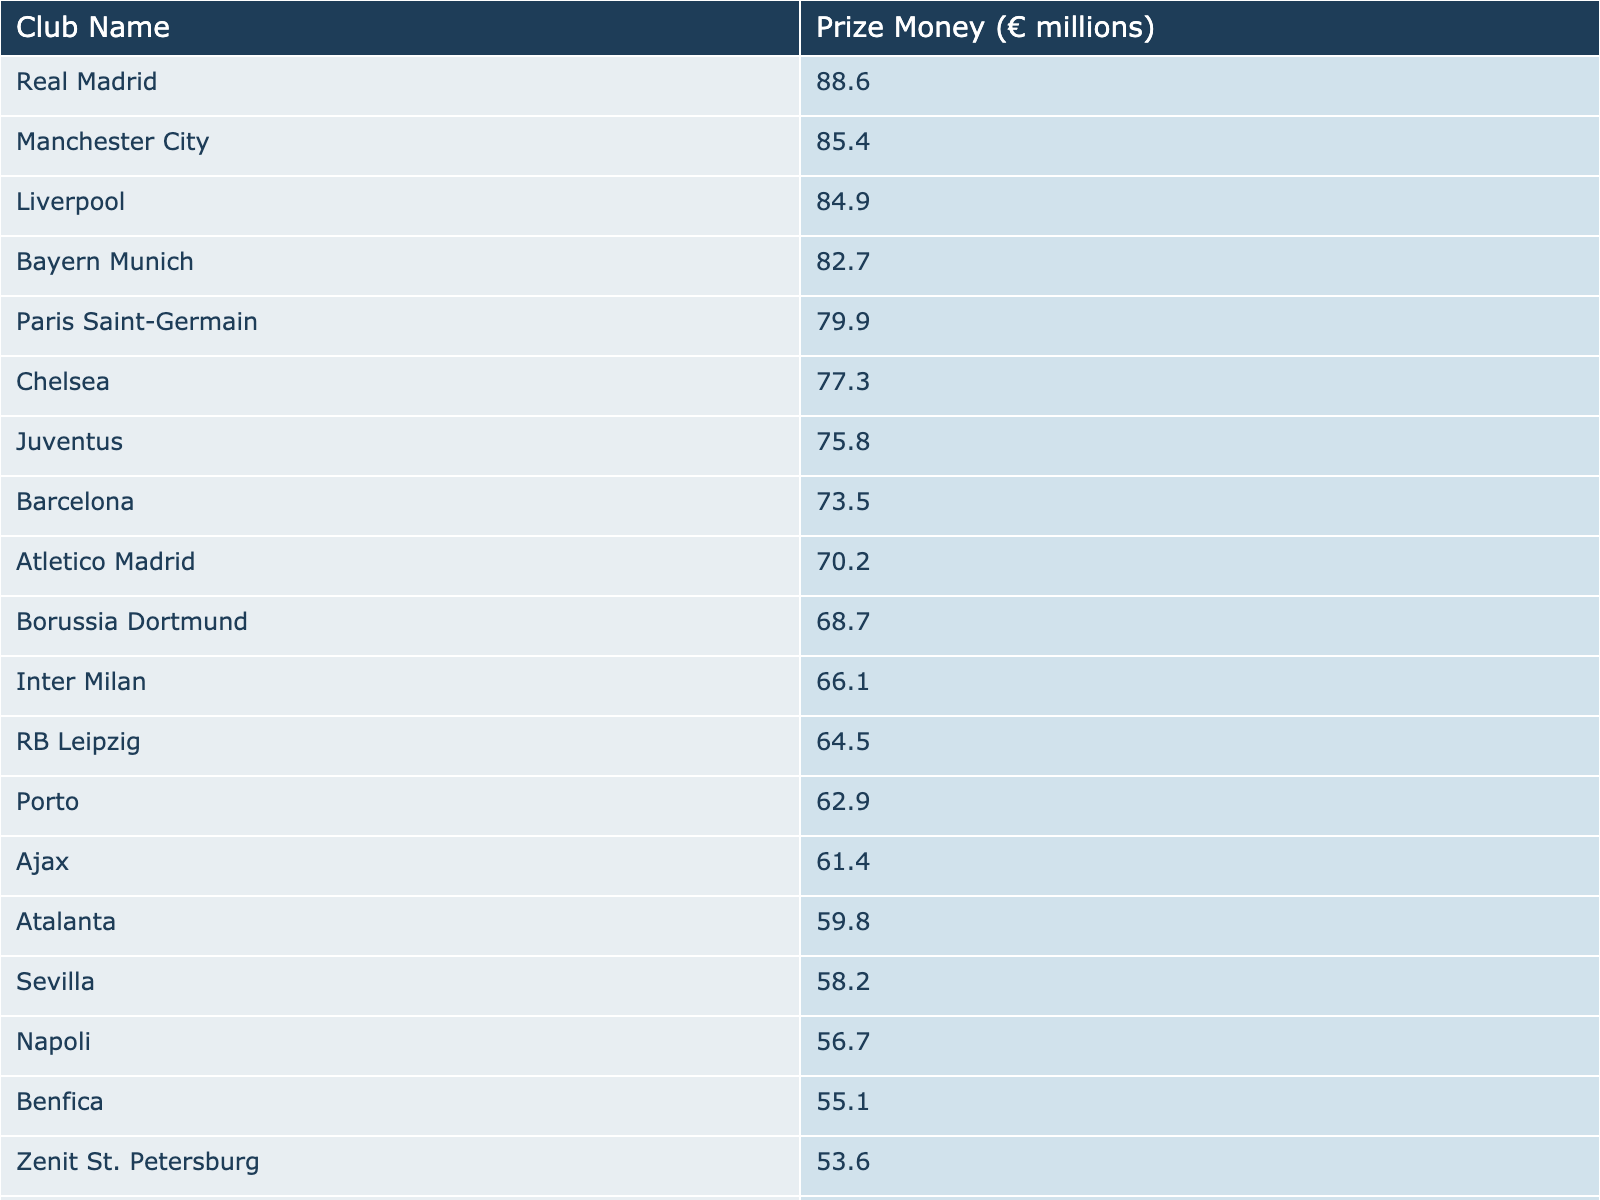What is the prize money for Manchester City? The table lists Manchester City with a prize money of €85.4 million.
Answer: 85.4 million Which club received the least prize money? By examining the table, Lyon has the least prize money listed at €52.0 million.
Answer: Lyon What is the prize money difference between Chelsea and Juventus? Chelsea's prize money is €77.3 million, while Juventus's is €75.8 million. The difference is €77.3 million - €75.8 million = €1.5 million.
Answer: 1.5 million How much total prize money did the top three clubs receive? The top three clubs' prize money sums up to €88.6 million (Real Madrid) + €85.4 million (Manchester City) + €84.9 million (Liverpool) = €258.9 million.
Answer: 258.9 million Is the prize money for Barcelona greater than that of RB Leipzig? Barcelona's prize money is €73.5 million and RB Leipzig's is €64.5 million; since €73.5 million > €64.5 million, the statement is true.
Answer: Yes What is the average prize money of the clubs listed in the table? There are 20 clubs. The total prize money is €1,440.6 million. The average is €1,440.6 million / 20 = €72.03 million.
Answer: 72.03 million Which club has a prize money greater than €70 million but less than €75 million? Reviewing the table, Atalanta with €59.8 million, Sevilla with €58.2 million, and Benfica with €55.1 million all fall short, meaning no club fits this criterion.
Answer: None If Real Madrid and Bayern Munich's prize money are combined, what is the total? Real Madrid has €88.6 million and Bayern Munich has €82.7 million. Their combined prize money is €88.6 million + €82.7 million = €171.3 million.
Answer: 171.3 million Which club ranks higher in prize money, Porto or Ajax? Porto has €62.9 million while Ajax has €61.4 million; therefore, Porto ranks higher.
Answer: Porto If all clubs received an equal share of €1 billion in total prize money, how much would each club receive? Each club would receive €1 billion / 20 clubs = €50 million per club.
Answer: 50 million 